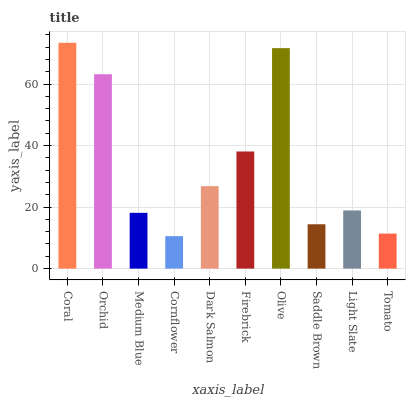Is Cornflower the minimum?
Answer yes or no. Yes. Is Coral the maximum?
Answer yes or no. Yes. Is Orchid the minimum?
Answer yes or no. No. Is Orchid the maximum?
Answer yes or no. No. Is Coral greater than Orchid?
Answer yes or no. Yes. Is Orchid less than Coral?
Answer yes or no. Yes. Is Orchid greater than Coral?
Answer yes or no. No. Is Coral less than Orchid?
Answer yes or no. No. Is Dark Salmon the high median?
Answer yes or no. Yes. Is Light Slate the low median?
Answer yes or no. Yes. Is Coral the high median?
Answer yes or no. No. Is Cornflower the low median?
Answer yes or no. No. 